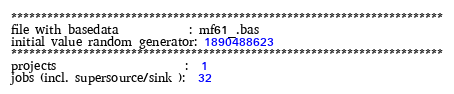Convert code to text. <code><loc_0><loc_0><loc_500><loc_500><_ObjectiveC_>************************************************************************
file with basedata            : mf61_.bas
initial value random generator: 1890488623
************************************************************************
projects                      :  1
jobs (incl. supersource/sink ):  32</code> 